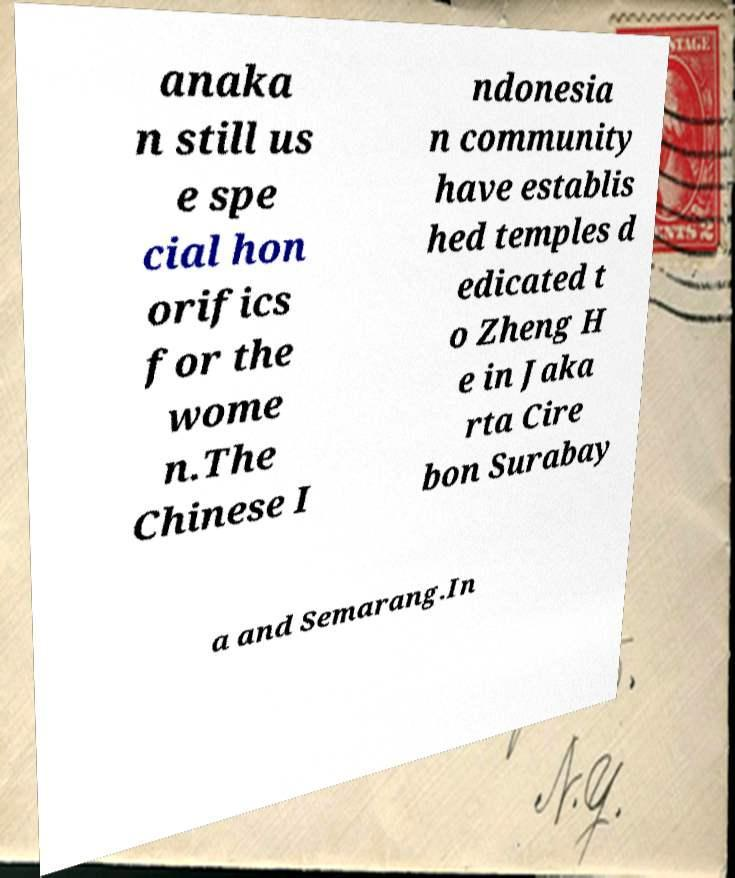Can you accurately transcribe the text from the provided image for me? anaka n still us e spe cial hon orifics for the wome n.The Chinese I ndonesia n community have establis hed temples d edicated t o Zheng H e in Jaka rta Cire bon Surabay a and Semarang.In 